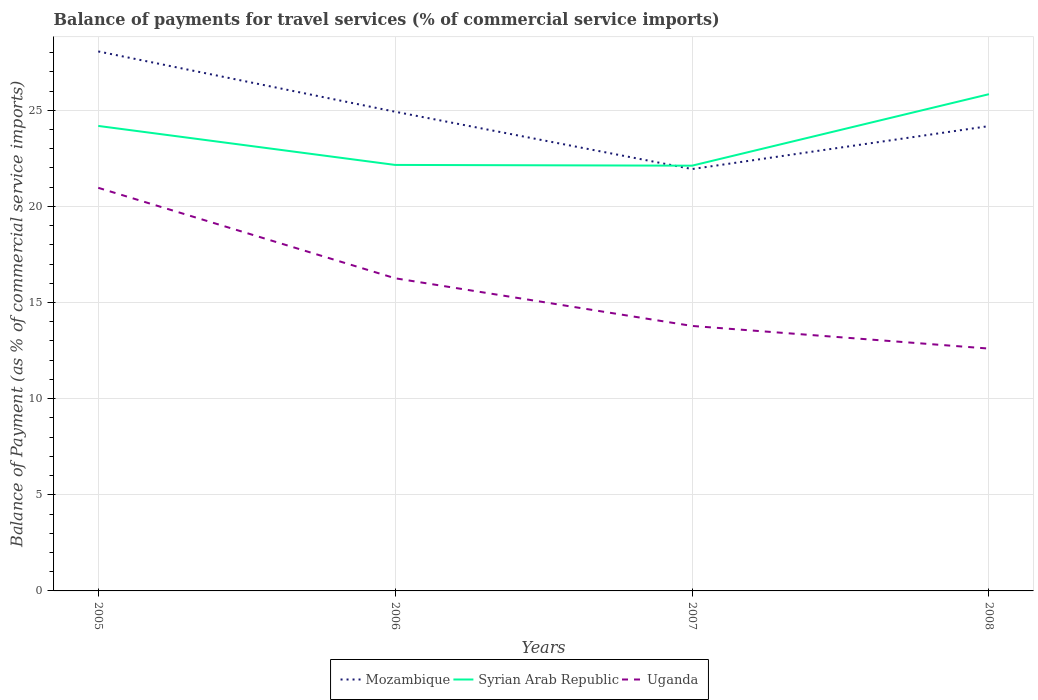How many different coloured lines are there?
Keep it short and to the point. 3. Does the line corresponding to Uganda intersect with the line corresponding to Mozambique?
Provide a short and direct response. No. Across all years, what is the maximum balance of payments for travel services in Mozambique?
Your answer should be very brief. 21.94. In which year was the balance of payments for travel services in Mozambique maximum?
Offer a terse response. 2007. What is the total balance of payments for travel services in Uganda in the graph?
Your response must be concise. 1.18. What is the difference between the highest and the second highest balance of payments for travel services in Mozambique?
Your answer should be compact. 6.12. Is the balance of payments for travel services in Syrian Arab Republic strictly greater than the balance of payments for travel services in Uganda over the years?
Your response must be concise. No. How many lines are there?
Give a very brief answer. 3. Does the graph contain grids?
Offer a terse response. Yes. How many legend labels are there?
Your answer should be compact. 3. How are the legend labels stacked?
Provide a short and direct response. Horizontal. What is the title of the graph?
Provide a succinct answer. Balance of payments for travel services (% of commercial service imports). What is the label or title of the X-axis?
Offer a very short reply. Years. What is the label or title of the Y-axis?
Your answer should be very brief. Balance of Payment (as % of commercial service imports). What is the Balance of Payment (as % of commercial service imports) of Mozambique in 2005?
Keep it short and to the point. 28.06. What is the Balance of Payment (as % of commercial service imports) in Syrian Arab Republic in 2005?
Keep it short and to the point. 24.19. What is the Balance of Payment (as % of commercial service imports) in Uganda in 2005?
Give a very brief answer. 20.97. What is the Balance of Payment (as % of commercial service imports) in Mozambique in 2006?
Ensure brevity in your answer.  24.93. What is the Balance of Payment (as % of commercial service imports) of Syrian Arab Republic in 2006?
Your answer should be very brief. 22.16. What is the Balance of Payment (as % of commercial service imports) in Uganda in 2006?
Offer a very short reply. 16.26. What is the Balance of Payment (as % of commercial service imports) in Mozambique in 2007?
Give a very brief answer. 21.94. What is the Balance of Payment (as % of commercial service imports) in Syrian Arab Republic in 2007?
Provide a succinct answer. 22.12. What is the Balance of Payment (as % of commercial service imports) in Uganda in 2007?
Ensure brevity in your answer.  13.78. What is the Balance of Payment (as % of commercial service imports) of Mozambique in 2008?
Ensure brevity in your answer.  24.18. What is the Balance of Payment (as % of commercial service imports) in Syrian Arab Republic in 2008?
Provide a succinct answer. 25.84. What is the Balance of Payment (as % of commercial service imports) of Uganda in 2008?
Keep it short and to the point. 12.61. Across all years, what is the maximum Balance of Payment (as % of commercial service imports) in Mozambique?
Provide a succinct answer. 28.06. Across all years, what is the maximum Balance of Payment (as % of commercial service imports) in Syrian Arab Republic?
Keep it short and to the point. 25.84. Across all years, what is the maximum Balance of Payment (as % of commercial service imports) of Uganda?
Make the answer very short. 20.97. Across all years, what is the minimum Balance of Payment (as % of commercial service imports) in Mozambique?
Your response must be concise. 21.94. Across all years, what is the minimum Balance of Payment (as % of commercial service imports) in Syrian Arab Republic?
Give a very brief answer. 22.12. Across all years, what is the minimum Balance of Payment (as % of commercial service imports) in Uganda?
Give a very brief answer. 12.61. What is the total Balance of Payment (as % of commercial service imports) in Mozambique in the graph?
Offer a very short reply. 99.11. What is the total Balance of Payment (as % of commercial service imports) in Syrian Arab Republic in the graph?
Offer a very short reply. 94.3. What is the total Balance of Payment (as % of commercial service imports) in Uganda in the graph?
Provide a short and direct response. 63.62. What is the difference between the Balance of Payment (as % of commercial service imports) of Mozambique in 2005 and that in 2006?
Keep it short and to the point. 3.14. What is the difference between the Balance of Payment (as % of commercial service imports) of Syrian Arab Republic in 2005 and that in 2006?
Provide a short and direct response. 2.03. What is the difference between the Balance of Payment (as % of commercial service imports) of Uganda in 2005 and that in 2006?
Make the answer very short. 4.71. What is the difference between the Balance of Payment (as % of commercial service imports) of Mozambique in 2005 and that in 2007?
Offer a very short reply. 6.12. What is the difference between the Balance of Payment (as % of commercial service imports) in Syrian Arab Republic in 2005 and that in 2007?
Give a very brief answer. 2.07. What is the difference between the Balance of Payment (as % of commercial service imports) of Uganda in 2005 and that in 2007?
Make the answer very short. 7.19. What is the difference between the Balance of Payment (as % of commercial service imports) of Mozambique in 2005 and that in 2008?
Your response must be concise. 3.88. What is the difference between the Balance of Payment (as % of commercial service imports) of Syrian Arab Republic in 2005 and that in 2008?
Your response must be concise. -1.65. What is the difference between the Balance of Payment (as % of commercial service imports) of Uganda in 2005 and that in 2008?
Your response must be concise. 8.36. What is the difference between the Balance of Payment (as % of commercial service imports) of Mozambique in 2006 and that in 2007?
Offer a very short reply. 2.98. What is the difference between the Balance of Payment (as % of commercial service imports) of Syrian Arab Republic in 2006 and that in 2007?
Make the answer very short. 0.04. What is the difference between the Balance of Payment (as % of commercial service imports) of Uganda in 2006 and that in 2007?
Your answer should be compact. 2.48. What is the difference between the Balance of Payment (as % of commercial service imports) in Mozambique in 2006 and that in 2008?
Offer a terse response. 0.75. What is the difference between the Balance of Payment (as % of commercial service imports) in Syrian Arab Republic in 2006 and that in 2008?
Provide a short and direct response. -3.68. What is the difference between the Balance of Payment (as % of commercial service imports) of Uganda in 2006 and that in 2008?
Give a very brief answer. 3.66. What is the difference between the Balance of Payment (as % of commercial service imports) of Mozambique in 2007 and that in 2008?
Your answer should be very brief. -2.23. What is the difference between the Balance of Payment (as % of commercial service imports) of Syrian Arab Republic in 2007 and that in 2008?
Provide a succinct answer. -3.72. What is the difference between the Balance of Payment (as % of commercial service imports) in Uganda in 2007 and that in 2008?
Offer a very short reply. 1.18. What is the difference between the Balance of Payment (as % of commercial service imports) in Mozambique in 2005 and the Balance of Payment (as % of commercial service imports) in Syrian Arab Republic in 2006?
Keep it short and to the point. 5.9. What is the difference between the Balance of Payment (as % of commercial service imports) of Mozambique in 2005 and the Balance of Payment (as % of commercial service imports) of Uganda in 2006?
Your answer should be very brief. 11.8. What is the difference between the Balance of Payment (as % of commercial service imports) of Syrian Arab Republic in 2005 and the Balance of Payment (as % of commercial service imports) of Uganda in 2006?
Give a very brief answer. 7.92. What is the difference between the Balance of Payment (as % of commercial service imports) of Mozambique in 2005 and the Balance of Payment (as % of commercial service imports) of Syrian Arab Republic in 2007?
Offer a very short reply. 5.94. What is the difference between the Balance of Payment (as % of commercial service imports) of Mozambique in 2005 and the Balance of Payment (as % of commercial service imports) of Uganda in 2007?
Provide a succinct answer. 14.28. What is the difference between the Balance of Payment (as % of commercial service imports) in Syrian Arab Republic in 2005 and the Balance of Payment (as % of commercial service imports) in Uganda in 2007?
Ensure brevity in your answer.  10.4. What is the difference between the Balance of Payment (as % of commercial service imports) of Mozambique in 2005 and the Balance of Payment (as % of commercial service imports) of Syrian Arab Republic in 2008?
Your answer should be very brief. 2.22. What is the difference between the Balance of Payment (as % of commercial service imports) of Mozambique in 2005 and the Balance of Payment (as % of commercial service imports) of Uganda in 2008?
Make the answer very short. 15.46. What is the difference between the Balance of Payment (as % of commercial service imports) of Syrian Arab Republic in 2005 and the Balance of Payment (as % of commercial service imports) of Uganda in 2008?
Give a very brief answer. 11.58. What is the difference between the Balance of Payment (as % of commercial service imports) in Mozambique in 2006 and the Balance of Payment (as % of commercial service imports) in Syrian Arab Republic in 2007?
Offer a very short reply. 2.81. What is the difference between the Balance of Payment (as % of commercial service imports) of Mozambique in 2006 and the Balance of Payment (as % of commercial service imports) of Uganda in 2007?
Provide a succinct answer. 11.14. What is the difference between the Balance of Payment (as % of commercial service imports) in Syrian Arab Republic in 2006 and the Balance of Payment (as % of commercial service imports) in Uganda in 2007?
Your response must be concise. 8.38. What is the difference between the Balance of Payment (as % of commercial service imports) of Mozambique in 2006 and the Balance of Payment (as % of commercial service imports) of Syrian Arab Republic in 2008?
Offer a terse response. -0.91. What is the difference between the Balance of Payment (as % of commercial service imports) in Mozambique in 2006 and the Balance of Payment (as % of commercial service imports) in Uganda in 2008?
Your response must be concise. 12.32. What is the difference between the Balance of Payment (as % of commercial service imports) of Syrian Arab Republic in 2006 and the Balance of Payment (as % of commercial service imports) of Uganda in 2008?
Your response must be concise. 9.55. What is the difference between the Balance of Payment (as % of commercial service imports) in Mozambique in 2007 and the Balance of Payment (as % of commercial service imports) in Syrian Arab Republic in 2008?
Give a very brief answer. -3.89. What is the difference between the Balance of Payment (as % of commercial service imports) in Mozambique in 2007 and the Balance of Payment (as % of commercial service imports) in Uganda in 2008?
Your answer should be compact. 9.34. What is the difference between the Balance of Payment (as % of commercial service imports) of Syrian Arab Republic in 2007 and the Balance of Payment (as % of commercial service imports) of Uganda in 2008?
Your answer should be very brief. 9.51. What is the average Balance of Payment (as % of commercial service imports) in Mozambique per year?
Your response must be concise. 24.78. What is the average Balance of Payment (as % of commercial service imports) of Syrian Arab Republic per year?
Make the answer very short. 23.58. What is the average Balance of Payment (as % of commercial service imports) in Uganda per year?
Keep it short and to the point. 15.9. In the year 2005, what is the difference between the Balance of Payment (as % of commercial service imports) of Mozambique and Balance of Payment (as % of commercial service imports) of Syrian Arab Republic?
Offer a terse response. 3.88. In the year 2005, what is the difference between the Balance of Payment (as % of commercial service imports) of Mozambique and Balance of Payment (as % of commercial service imports) of Uganda?
Offer a very short reply. 7.09. In the year 2005, what is the difference between the Balance of Payment (as % of commercial service imports) of Syrian Arab Republic and Balance of Payment (as % of commercial service imports) of Uganda?
Offer a terse response. 3.22. In the year 2006, what is the difference between the Balance of Payment (as % of commercial service imports) of Mozambique and Balance of Payment (as % of commercial service imports) of Syrian Arab Republic?
Provide a short and direct response. 2.77. In the year 2006, what is the difference between the Balance of Payment (as % of commercial service imports) of Mozambique and Balance of Payment (as % of commercial service imports) of Uganda?
Keep it short and to the point. 8.66. In the year 2006, what is the difference between the Balance of Payment (as % of commercial service imports) in Syrian Arab Republic and Balance of Payment (as % of commercial service imports) in Uganda?
Keep it short and to the point. 5.9. In the year 2007, what is the difference between the Balance of Payment (as % of commercial service imports) of Mozambique and Balance of Payment (as % of commercial service imports) of Syrian Arab Republic?
Your response must be concise. -0.18. In the year 2007, what is the difference between the Balance of Payment (as % of commercial service imports) of Mozambique and Balance of Payment (as % of commercial service imports) of Uganda?
Your answer should be compact. 8.16. In the year 2007, what is the difference between the Balance of Payment (as % of commercial service imports) in Syrian Arab Republic and Balance of Payment (as % of commercial service imports) in Uganda?
Provide a short and direct response. 8.34. In the year 2008, what is the difference between the Balance of Payment (as % of commercial service imports) of Mozambique and Balance of Payment (as % of commercial service imports) of Syrian Arab Republic?
Keep it short and to the point. -1.66. In the year 2008, what is the difference between the Balance of Payment (as % of commercial service imports) in Mozambique and Balance of Payment (as % of commercial service imports) in Uganda?
Offer a very short reply. 11.57. In the year 2008, what is the difference between the Balance of Payment (as % of commercial service imports) of Syrian Arab Republic and Balance of Payment (as % of commercial service imports) of Uganda?
Ensure brevity in your answer.  13.23. What is the ratio of the Balance of Payment (as % of commercial service imports) of Mozambique in 2005 to that in 2006?
Keep it short and to the point. 1.13. What is the ratio of the Balance of Payment (as % of commercial service imports) in Syrian Arab Republic in 2005 to that in 2006?
Provide a short and direct response. 1.09. What is the ratio of the Balance of Payment (as % of commercial service imports) of Uganda in 2005 to that in 2006?
Provide a short and direct response. 1.29. What is the ratio of the Balance of Payment (as % of commercial service imports) in Mozambique in 2005 to that in 2007?
Your answer should be compact. 1.28. What is the ratio of the Balance of Payment (as % of commercial service imports) in Syrian Arab Republic in 2005 to that in 2007?
Provide a succinct answer. 1.09. What is the ratio of the Balance of Payment (as % of commercial service imports) in Uganda in 2005 to that in 2007?
Make the answer very short. 1.52. What is the ratio of the Balance of Payment (as % of commercial service imports) of Mozambique in 2005 to that in 2008?
Provide a short and direct response. 1.16. What is the ratio of the Balance of Payment (as % of commercial service imports) in Syrian Arab Republic in 2005 to that in 2008?
Your answer should be very brief. 0.94. What is the ratio of the Balance of Payment (as % of commercial service imports) in Uganda in 2005 to that in 2008?
Your answer should be very brief. 1.66. What is the ratio of the Balance of Payment (as % of commercial service imports) of Mozambique in 2006 to that in 2007?
Your response must be concise. 1.14. What is the ratio of the Balance of Payment (as % of commercial service imports) in Syrian Arab Republic in 2006 to that in 2007?
Give a very brief answer. 1. What is the ratio of the Balance of Payment (as % of commercial service imports) of Uganda in 2006 to that in 2007?
Ensure brevity in your answer.  1.18. What is the ratio of the Balance of Payment (as % of commercial service imports) of Mozambique in 2006 to that in 2008?
Offer a very short reply. 1.03. What is the ratio of the Balance of Payment (as % of commercial service imports) in Syrian Arab Republic in 2006 to that in 2008?
Your answer should be very brief. 0.86. What is the ratio of the Balance of Payment (as % of commercial service imports) of Uganda in 2006 to that in 2008?
Your answer should be compact. 1.29. What is the ratio of the Balance of Payment (as % of commercial service imports) of Mozambique in 2007 to that in 2008?
Keep it short and to the point. 0.91. What is the ratio of the Balance of Payment (as % of commercial service imports) of Syrian Arab Republic in 2007 to that in 2008?
Give a very brief answer. 0.86. What is the ratio of the Balance of Payment (as % of commercial service imports) of Uganda in 2007 to that in 2008?
Provide a short and direct response. 1.09. What is the difference between the highest and the second highest Balance of Payment (as % of commercial service imports) in Mozambique?
Your answer should be very brief. 3.14. What is the difference between the highest and the second highest Balance of Payment (as % of commercial service imports) in Syrian Arab Republic?
Keep it short and to the point. 1.65. What is the difference between the highest and the second highest Balance of Payment (as % of commercial service imports) in Uganda?
Offer a very short reply. 4.71. What is the difference between the highest and the lowest Balance of Payment (as % of commercial service imports) of Mozambique?
Your response must be concise. 6.12. What is the difference between the highest and the lowest Balance of Payment (as % of commercial service imports) of Syrian Arab Republic?
Your answer should be very brief. 3.72. What is the difference between the highest and the lowest Balance of Payment (as % of commercial service imports) in Uganda?
Your answer should be compact. 8.36. 